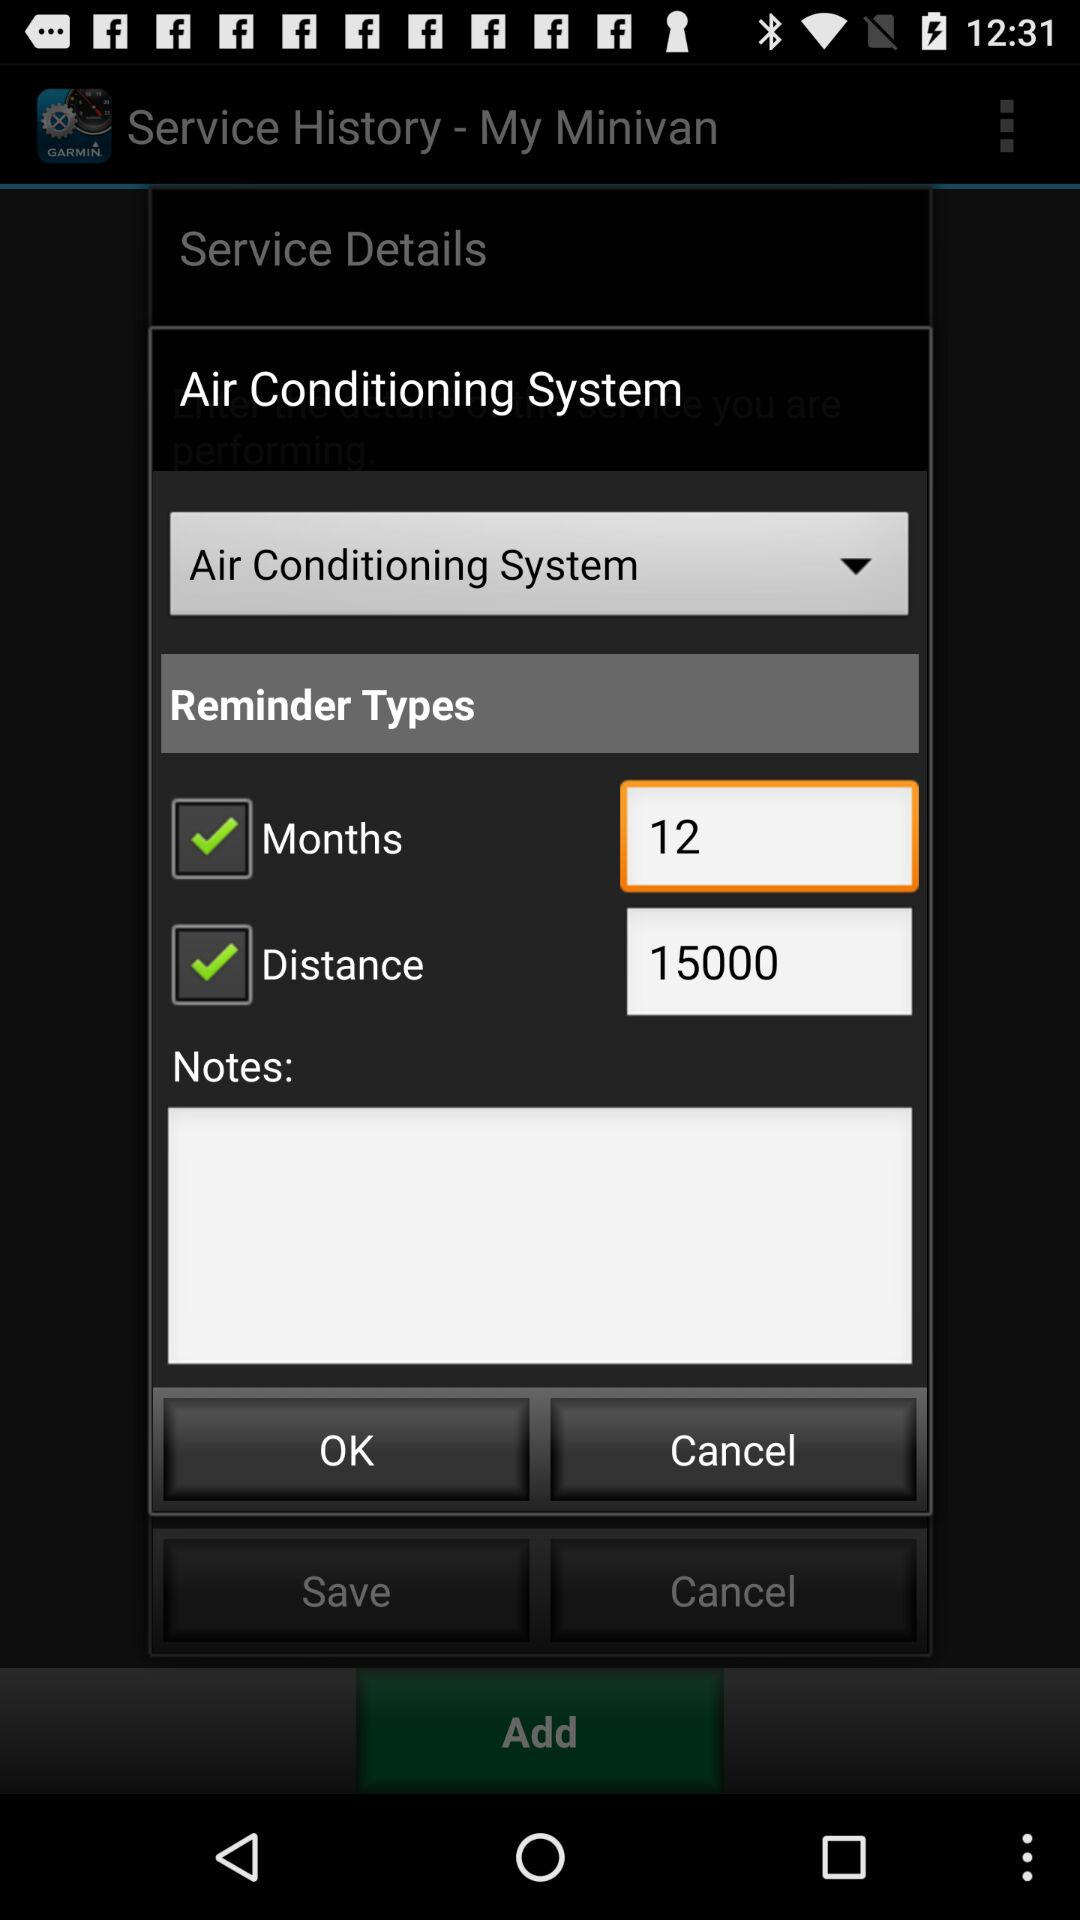How much distance is displayed in the reminder types? The displayed distance in the reminder types is 15000. 